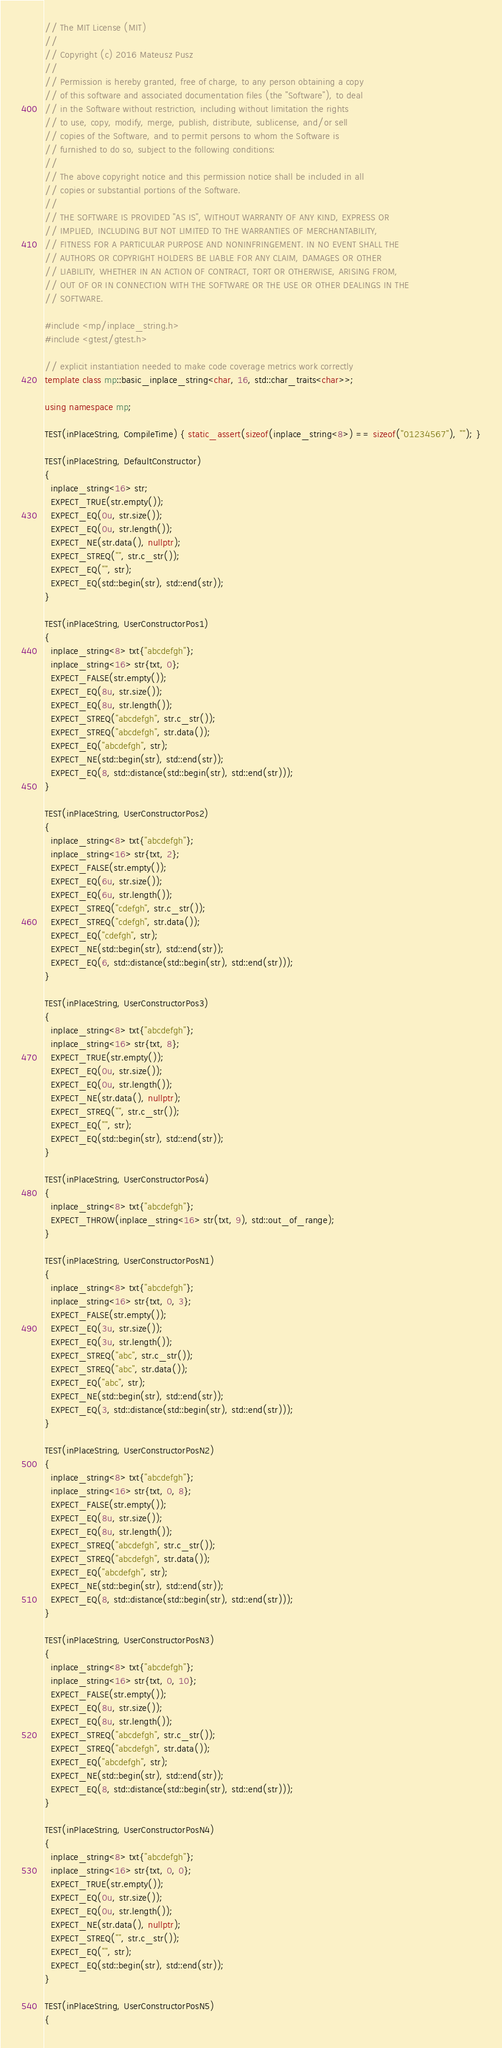Convert code to text. <code><loc_0><loc_0><loc_500><loc_500><_C++_>// The MIT License (MIT)
//
// Copyright (c) 2016 Mateusz Pusz
//
// Permission is hereby granted, free of charge, to any person obtaining a copy
// of this software and associated documentation files (the "Software"), to deal
// in the Software without restriction, including without limitation the rights
// to use, copy, modify, merge, publish, distribute, sublicense, and/or sell
// copies of the Software, and to permit persons to whom the Software is
// furnished to do so, subject to the following conditions:
//
// The above copyright notice and this permission notice shall be included in all
// copies or substantial portions of the Software.
//
// THE SOFTWARE IS PROVIDED "AS IS", WITHOUT WARRANTY OF ANY KIND, EXPRESS OR
// IMPLIED, INCLUDING BUT NOT LIMITED TO THE WARRANTIES OF MERCHANTABILITY,
// FITNESS FOR A PARTICULAR PURPOSE AND NONINFRINGEMENT. IN NO EVENT SHALL THE
// AUTHORS OR COPYRIGHT HOLDERS BE LIABLE FOR ANY CLAIM, DAMAGES OR OTHER
// LIABILITY, WHETHER IN AN ACTION OF CONTRACT, TORT OR OTHERWISE, ARISING FROM,
// OUT OF OR IN CONNECTION WITH THE SOFTWARE OR THE USE OR OTHER DEALINGS IN THE
// SOFTWARE.

#include <mp/inplace_string.h>
#include <gtest/gtest.h>

// explicit instantiation needed to make code coverage metrics work correctly
template class mp::basic_inplace_string<char, 16, std::char_traits<char>>;

using namespace mp;

TEST(inPlaceString, CompileTime) { static_assert(sizeof(inplace_string<8>) == sizeof("01234567"), ""); }

TEST(inPlaceString, DefaultConstructor)
{
  inplace_string<16> str;
  EXPECT_TRUE(str.empty());
  EXPECT_EQ(0u, str.size());
  EXPECT_EQ(0u, str.length());
  EXPECT_NE(str.data(), nullptr);
  EXPECT_STREQ("", str.c_str());
  EXPECT_EQ("", str);
  EXPECT_EQ(std::begin(str), std::end(str));
}

TEST(inPlaceString, UserConstructorPos1)
{
  inplace_string<8> txt{"abcdefgh"};
  inplace_string<16> str{txt, 0};
  EXPECT_FALSE(str.empty());
  EXPECT_EQ(8u, str.size());
  EXPECT_EQ(8u, str.length());
  EXPECT_STREQ("abcdefgh", str.c_str());
  EXPECT_STREQ("abcdefgh", str.data());
  EXPECT_EQ("abcdefgh", str);
  EXPECT_NE(std::begin(str), std::end(str));
  EXPECT_EQ(8, std::distance(std::begin(str), std::end(str)));
}

TEST(inPlaceString, UserConstructorPos2)
{
  inplace_string<8> txt{"abcdefgh"};
  inplace_string<16> str{txt, 2};
  EXPECT_FALSE(str.empty());
  EXPECT_EQ(6u, str.size());
  EXPECT_EQ(6u, str.length());
  EXPECT_STREQ("cdefgh", str.c_str());
  EXPECT_STREQ("cdefgh", str.data());
  EXPECT_EQ("cdefgh", str);
  EXPECT_NE(std::begin(str), std::end(str));
  EXPECT_EQ(6, std::distance(std::begin(str), std::end(str)));
}

TEST(inPlaceString, UserConstructorPos3)
{
  inplace_string<8> txt{"abcdefgh"};
  inplace_string<16> str{txt, 8};
  EXPECT_TRUE(str.empty());
  EXPECT_EQ(0u, str.size());
  EXPECT_EQ(0u, str.length());
  EXPECT_NE(str.data(), nullptr);
  EXPECT_STREQ("", str.c_str());
  EXPECT_EQ("", str);
  EXPECT_EQ(std::begin(str), std::end(str));
}

TEST(inPlaceString, UserConstructorPos4)
{
  inplace_string<8> txt{"abcdefgh"};
  EXPECT_THROW(inplace_string<16> str(txt, 9), std::out_of_range);
}

TEST(inPlaceString, UserConstructorPosN1)
{
  inplace_string<8> txt{"abcdefgh"};
  inplace_string<16> str{txt, 0, 3};
  EXPECT_FALSE(str.empty());
  EXPECT_EQ(3u, str.size());
  EXPECT_EQ(3u, str.length());
  EXPECT_STREQ("abc", str.c_str());
  EXPECT_STREQ("abc", str.data());
  EXPECT_EQ("abc", str);
  EXPECT_NE(std::begin(str), std::end(str));
  EXPECT_EQ(3, std::distance(std::begin(str), std::end(str)));
}

TEST(inPlaceString, UserConstructorPosN2)
{
  inplace_string<8> txt{"abcdefgh"};
  inplace_string<16> str{txt, 0, 8};
  EXPECT_FALSE(str.empty());
  EXPECT_EQ(8u, str.size());
  EXPECT_EQ(8u, str.length());
  EXPECT_STREQ("abcdefgh", str.c_str());
  EXPECT_STREQ("abcdefgh", str.data());
  EXPECT_EQ("abcdefgh", str);
  EXPECT_NE(std::begin(str), std::end(str));
  EXPECT_EQ(8, std::distance(std::begin(str), std::end(str)));
}

TEST(inPlaceString, UserConstructorPosN3)
{
  inplace_string<8> txt{"abcdefgh"};
  inplace_string<16> str{txt, 0, 10};
  EXPECT_FALSE(str.empty());
  EXPECT_EQ(8u, str.size());
  EXPECT_EQ(8u, str.length());
  EXPECT_STREQ("abcdefgh", str.c_str());
  EXPECT_STREQ("abcdefgh", str.data());
  EXPECT_EQ("abcdefgh", str);
  EXPECT_NE(std::begin(str), std::end(str));
  EXPECT_EQ(8, std::distance(std::begin(str), std::end(str)));
}

TEST(inPlaceString, UserConstructorPosN4)
{
  inplace_string<8> txt{"abcdefgh"};
  inplace_string<16> str{txt, 0, 0};
  EXPECT_TRUE(str.empty());
  EXPECT_EQ(0u, str.size());
  EXPECT_EQ(0u, str.length());
  EXPECT_NE(str.data(), nullptr);
  EXPECT_STREQ("", str.c_str());
  EXPECT_EQ("", str);
  EXPECT_EQ(std::begin(str), std::end(str));
}

TEST(inPlaceString, UserConstructorPosN5)
{</code> 